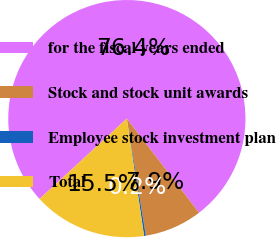<chart> <loc_0><loc_0><loc_500><loc_500><pie_chart><fcel>for the fiscal years ended<fcel>Stock and stock unit awards<fcel>Employee stock investment plan<fcel>Total<nl><fcel>76.42%<fcel>7.86%<fcel>0.24%<fcel>15.48%<nl></chart> 